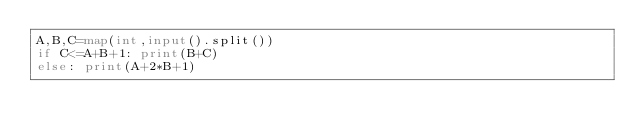Convert code to text. <code><loc_0><loc_0><loc_500><loc_500><_Python_>A,B,C=map(int,input().split())
if C<=A+B+1: print(B+C)
else: print(A+2*B+1)</code> 